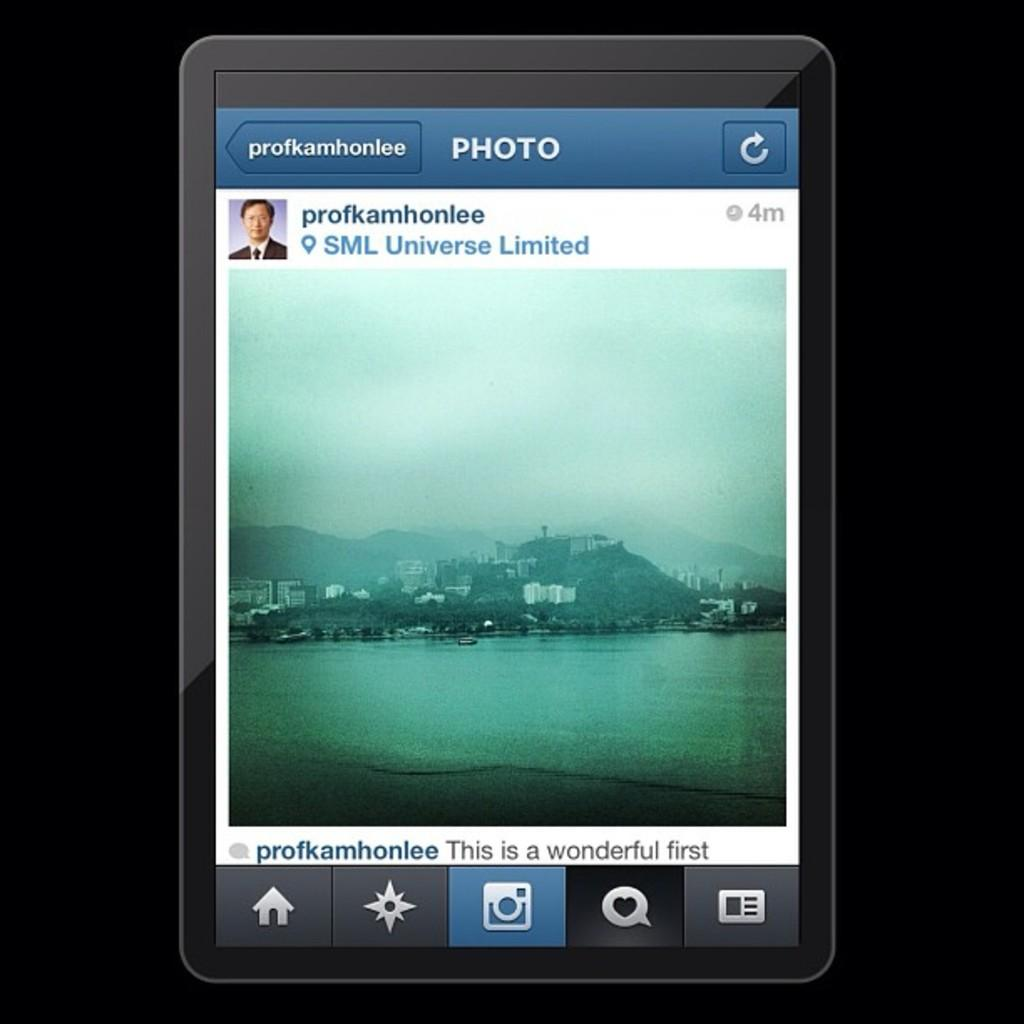<image>
Create a compact narrative representing the image presented. A tablet screen shows a photo posted by profkamhonlee. 